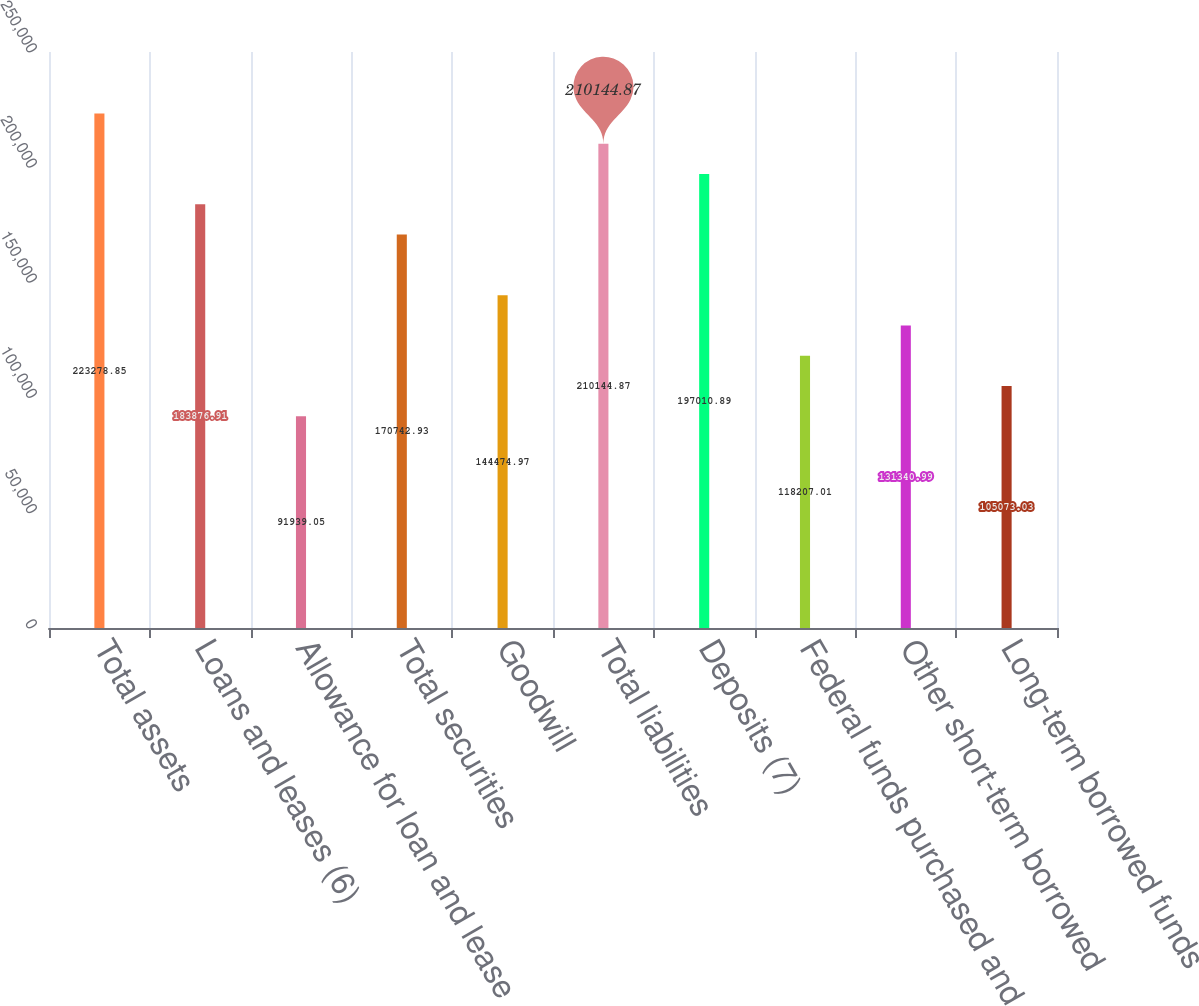Convert chart to OTSL. <chart><loc_0><loc_0><loc_500><loc_500><bar_chart><fcel>Total assets<fcel>Loans and leases (6)<fcel>Allowance for loan and lease<fcel>Total securities<fcel>Goodwill<fcel>Total liabilities<fcel>Deposits (7)<fcel>Federal funds purchased and<fcel>Other short-term borrowed<fcel>Long-term borrowed funds<nl><fcel>223279<fcel>183877<fcel>91939.1<fcel>170743<fcel>144475<fcel>210145<fcel>197011<fcel>118207<fcel>131341<fcel>105073<nl></chart> 